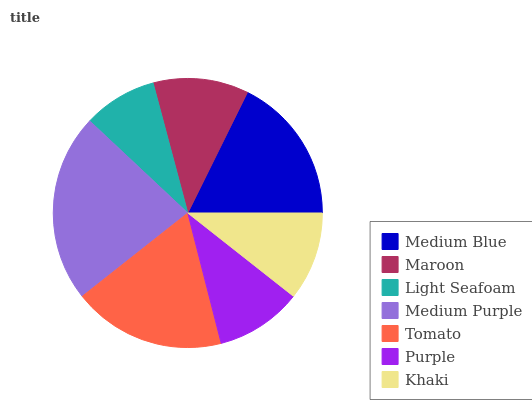Is Light Seafoam the minimum?
Answer yes or no. Yes. Is Medium Purple the maximum?
Answer yes or no. Yes. Is Maroon the minimum?
Answer yes or no. No. Is Maroon the maximum?
Answer yes or no. No. Is Medium Blue greater than Maroon?
Answer yes or no. Yes. Is Maroon less than Medium Blue?
Answer yes or no. Yes. Is Maroon greater than Medium Blue?
Answer yes or no. No. Is Medium Blue less than Maroon?
Answer yes or no. No. Is Maroon the high median?
Answer yes or no. Yes. Is Maroon the low median?
Answer yes or no. Yes. Is Tomato the high median?
Answer yes or no. No. Is Purple the low median?
Answer yes or no. No. 